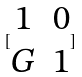<formula> <loc_0><loc_0><loc_500><loc_500>[ \begin{matrix} 1 & 0 \\ G & 1 \end{matrix} ]</formula> 